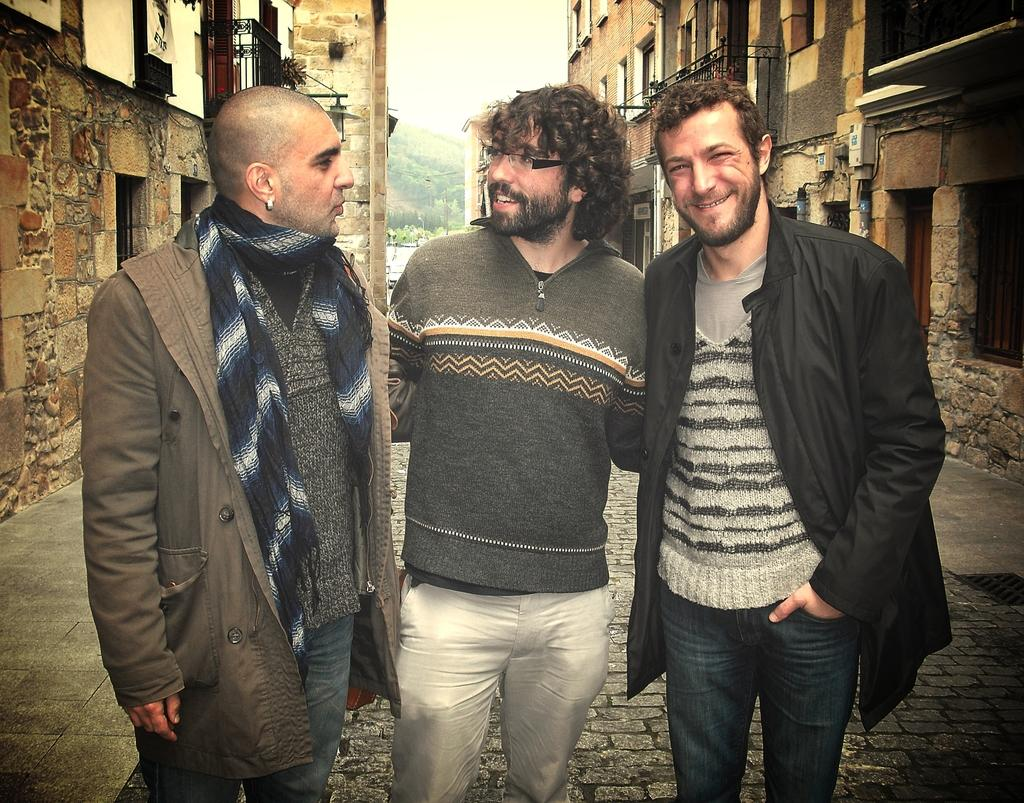How many people are in the image? There are three men standing in the image. What can be seen in the background of the image? There are buildings in the background of the image. What is visible in the sky in the image? The sky is visible in the image. What type of milk is being poured by one of the men in the image? There is no milk present in the image; it features three men standing and buildings in the background. 